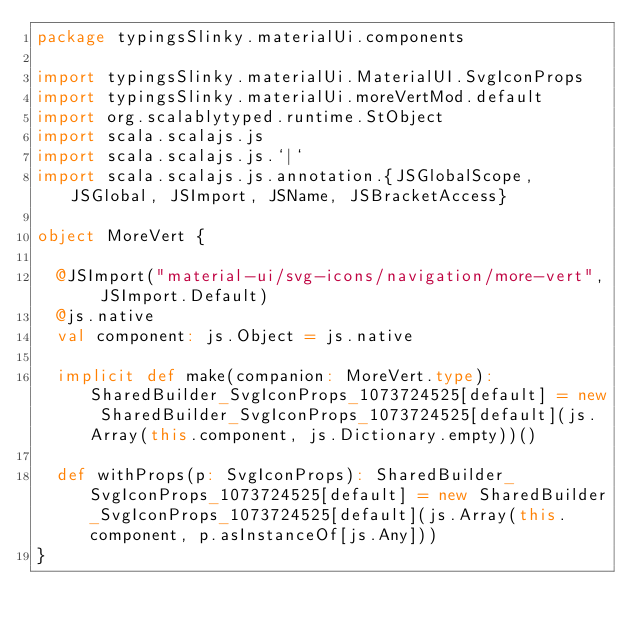Convert code to text. <code><loc_0><loc_0><loc_500><loc_500><_Scala_>package typingsSlinky.materialUi.components

import typingsSlinky.materialUi.MaterialUI.SvgIconProps
import typingsSlinky.materialUi.moreVertMod.default
import org.scalablytyped.runtime.StObject
import scala.scalajs.js
import scala.scalajs.js.`|`
import scala.scalajs.js.annotation.{JSGlobalScope, JSGlobal, JSImport, JSName, JSBracketAccess}

object MoreVert {
  
  @JSImport("material-ui/svg-icons/navigation/more-vert", JSImport.Default)
  @js.native
  val component: js.Object = js.native
  
  implicit def make(companion: MoreVert.type): SharedBuilder_SvgIconProps_1073724525[default] = new SharedBuilder_SvgIconProps_1073724525[default](js.Array(this.component, js.Dictionary.empty))()
  
  def withProps(p: SvgIconProps): SharedBuilder_SvgIconProps_1073724525[default] = new SharedBuilder_SvgIconProps_1073724525[default](js.Array(this.component, p.asInstanceOf[js.Any]))
}
</code> 